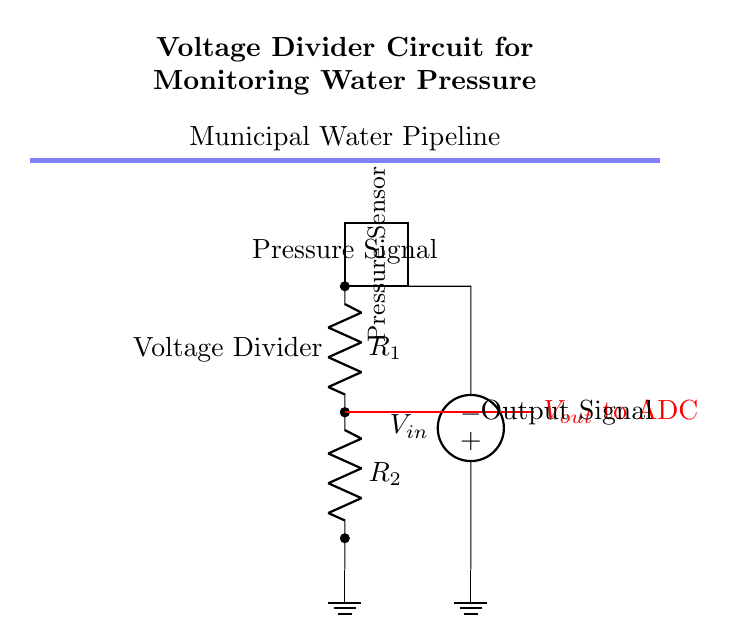What is the input voltage in this circuit? The input voltage is labeled as \( V_{in} \) in the circuit diagram, indicating the voltage supplied to the voltage divider.
Answer: Vin What are the two resistors used in the voltage divider? The two resistors are named \( R_1 \) and \( R_2 \) in the circuit, which form the voltage divider necessary for monitoring the pressure signal.
Answer: R1 and R2 What is the output voltage connected to? The output voltage \( V_{out} \) is connected to an Analog-to-Digital Converter (ADC) in order to convert the voltage signal into a digital form for processing.
Answer: ADC How does the voltage divider affect the output voltage? The output voltage \( V_{out} \) is determined by the ratio of the resistances \( R_1 \) and \( R_2 \) according to the voltage divider formula \( V_{out} = V_{in} \cdot \frac{R_2}{R_1 + R_2} \), effectively scaling the input voltage based on these resistances.
Answer: It scales Vin What is the role of the pressure sensor in this circuit? The pressure sensor measures the water pressure in the municipal pipeline and converts it into a proportional electrical signal, which is then processed by the voltage divider circuit.
Answer: Measure water pressure What happens if one of the resistors fails? If one of the resistors fails, it alters the voltage divider ratio, which impacts the output voltage \( V_{out} \) and may lead to incorrect pressure readings by the ADC, potentially causing system failure or misreading.
Answer: Affects output voltage 